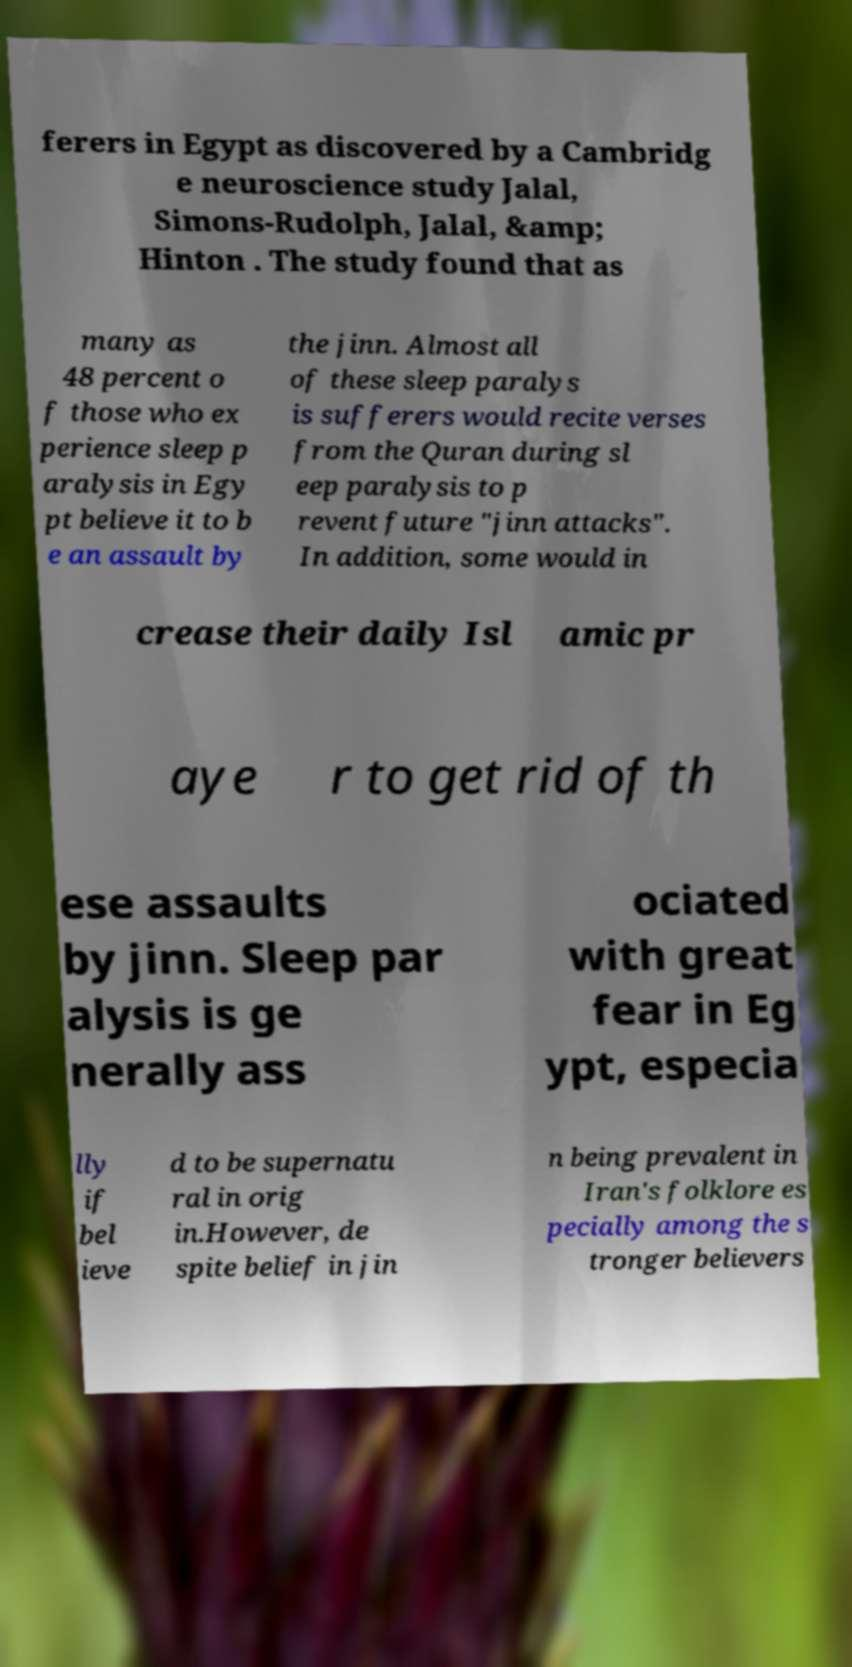For documentation purposes, I need the text within this image transcribed. Could you provide that? ferers in Egypt as discovered by a Cambridg e neuroscience study Jalal, Simons-Rudolph, Jalal, &amp; Hinton . The study found that as many as 48 percent o f those who ex perience sleep p aralysis in Egy pt believe it to b e an assault by the jinn. Almost all of these sleep paralys is sufferers would recite verses from the Quran during sl eep paralysis to p revent future "jinn attacks". In addition, some would in crease their daily Isl amic pr aye r to get rid of th ese assaults by jinn. Sleep par alysis is ge nerally ass ociated with great fear in Eg ypt, especia lly if bel ieve d to be supernatu ral in orig in.However, de spite belief in jin n being prevalent in Iran's folklore es pecially among the s tronger believers 